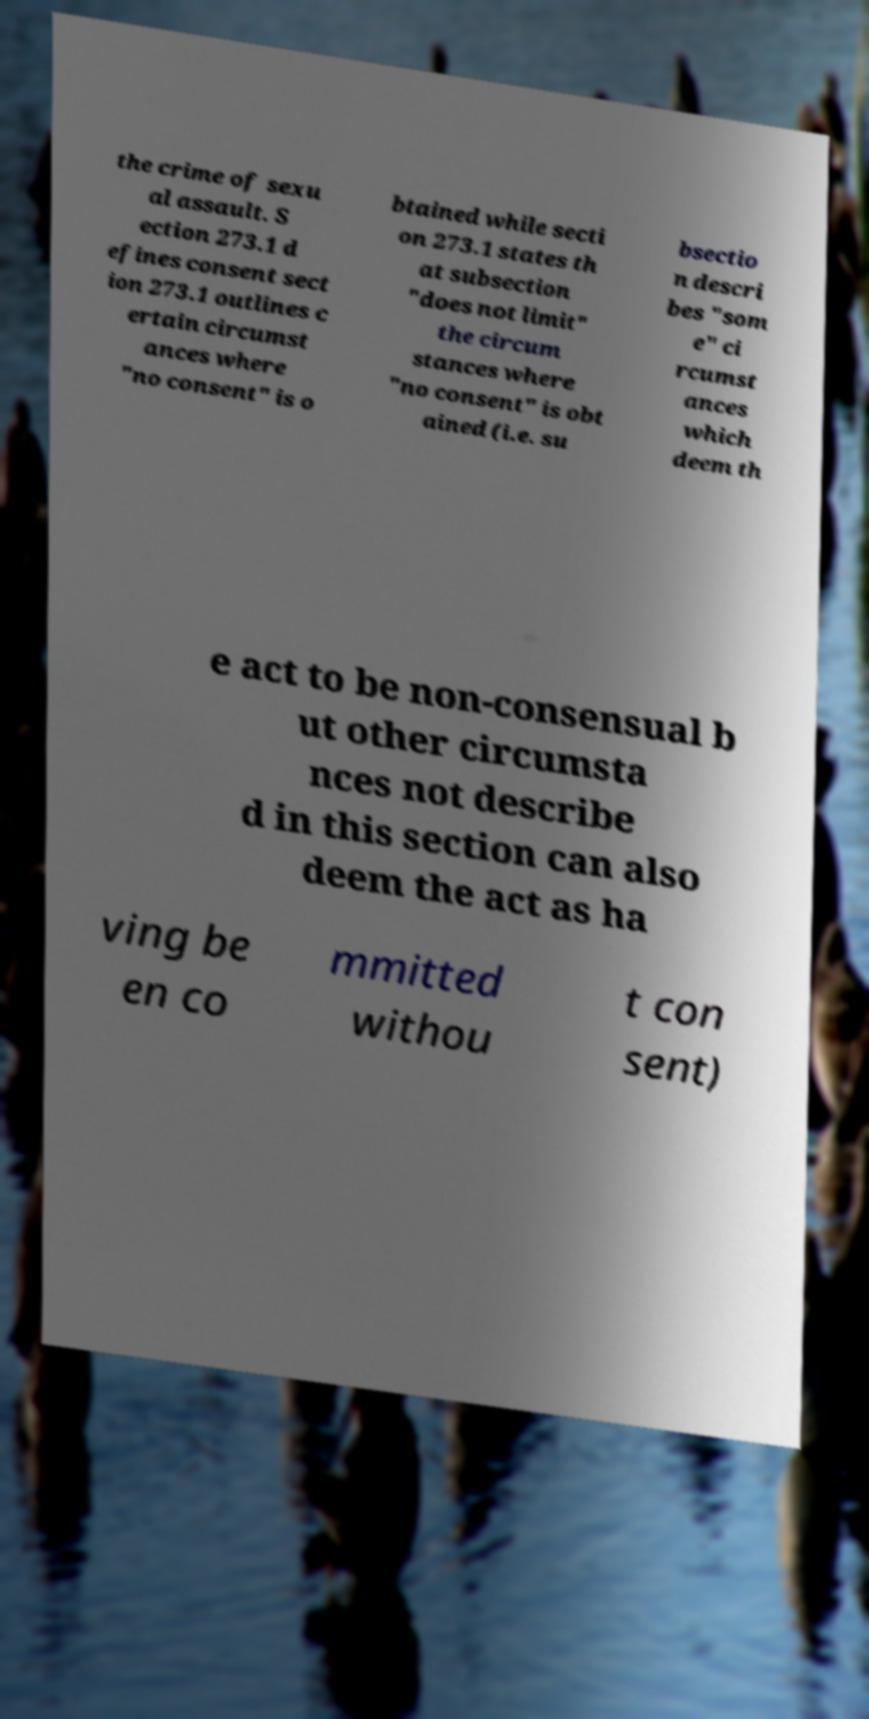For documentation purposes, I need the text within this image transcribed. Could you provide that? the crime of sexu al assault. S ection 273.1 d efines consent sect ion 273.1 outlines c ertain circumst ances where "no consent" is o btained while secti on 273.1 states th at subsection "does not limit" the circum stances where "no consent" is obt ained (i.e. su bsectio n descri bes "som e" ci rcumst ances which deem th e act to be non-consensual b ut other circumsta nces not describe d in this section can also deem the act as ha ving be en co mmitted withou t con sent) 